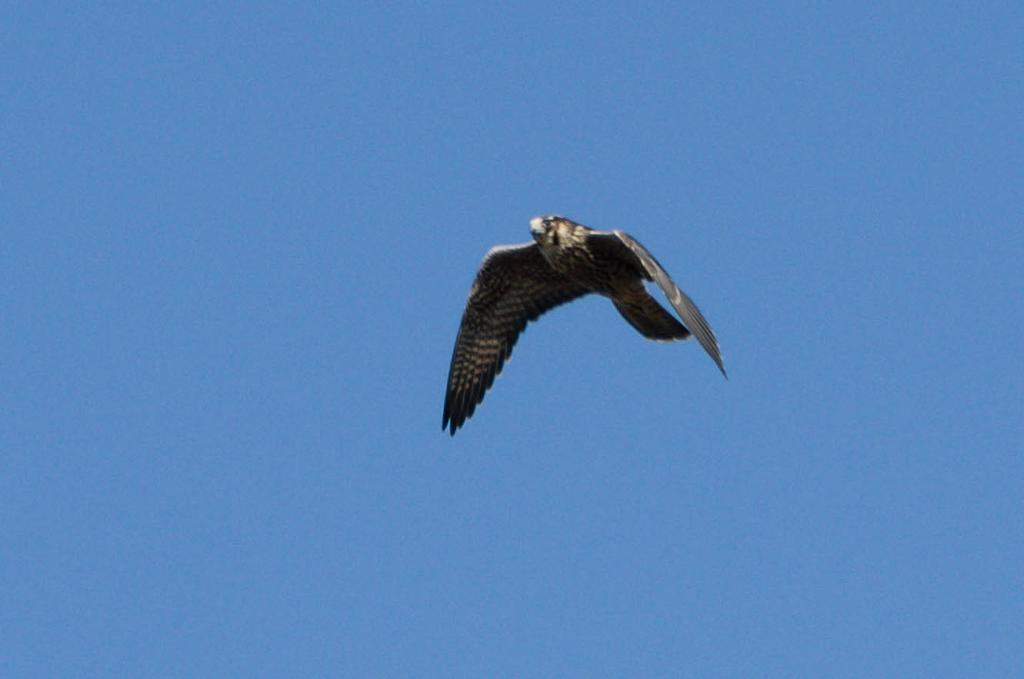What type of animal is present in the image? There is a bird in the image. What is the bird doing in the image? The bird is flying in the sky. Reasoning: Let's think step by step by step in order to produce the conversation. We start by identifying the main subject in the image, which is the bird. Then, we expand the conversation to include the action of the bird, which is flying in the sky. Each question is designed to elicit a specific detail about the image that is known from the provided facts. Absurd Question/Answer: What is the name of the bird's daughter in the image? There is no mention of a bird's daughter in the image, as it only shows a bird flying in the sky. 